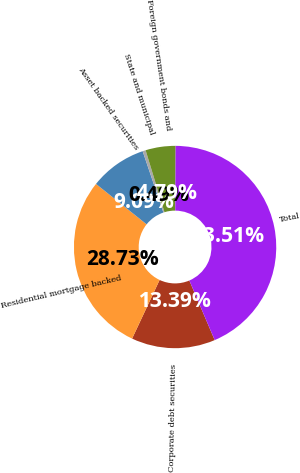Convert chart to OTSL. <chart><loc_0><loc_0><loc_500><loc_500><pie_chart><fcel>Corporate debt securities<fcel>Residential mortgage backed<fcel>Asset backed securities<fcel>State and municipal<fcel>Foreign government bonds and<fcel>Total<nl><fcel>13.39%<fcel>28.73%<fcel>9.09%<fcel>0.49%<fcel>4.79%<fcel>43.51%<nl></chart> 